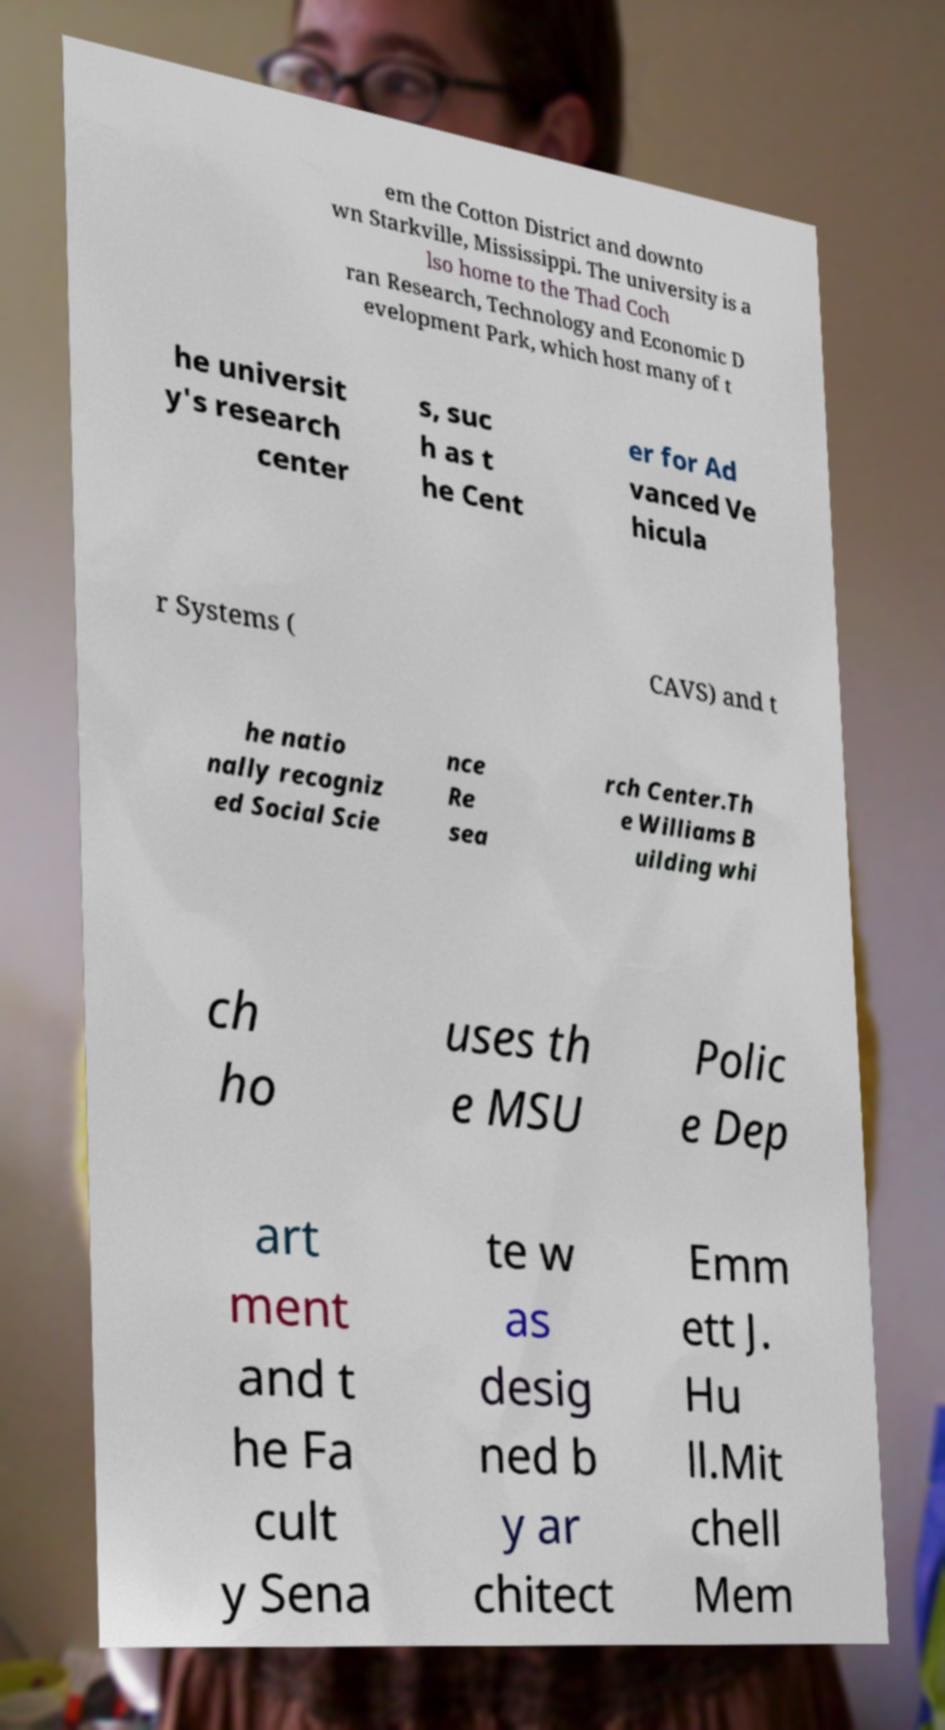Please identify and transcribe the text found in this image. em the Cotton District and downto wn Starkville, Mississippi. The university is a lso home to the Thad Coch ran Research, Technology and Economic D evelopment Park, which host many of t he universit y's research center s, suc h as t he Cent er for Ad vanced Ve hicula r Systems ( CAVS) and t he natio nally recogniz ed Social Scie nce Re sea rch Center.Th e Williams B uilding whi ch ho uses th e MSU Polic e Dep art ment and t he Fa cult y Sena te w as desig ned b y ar chitect Emm ett J. Hu ll.Mit chell Mem 